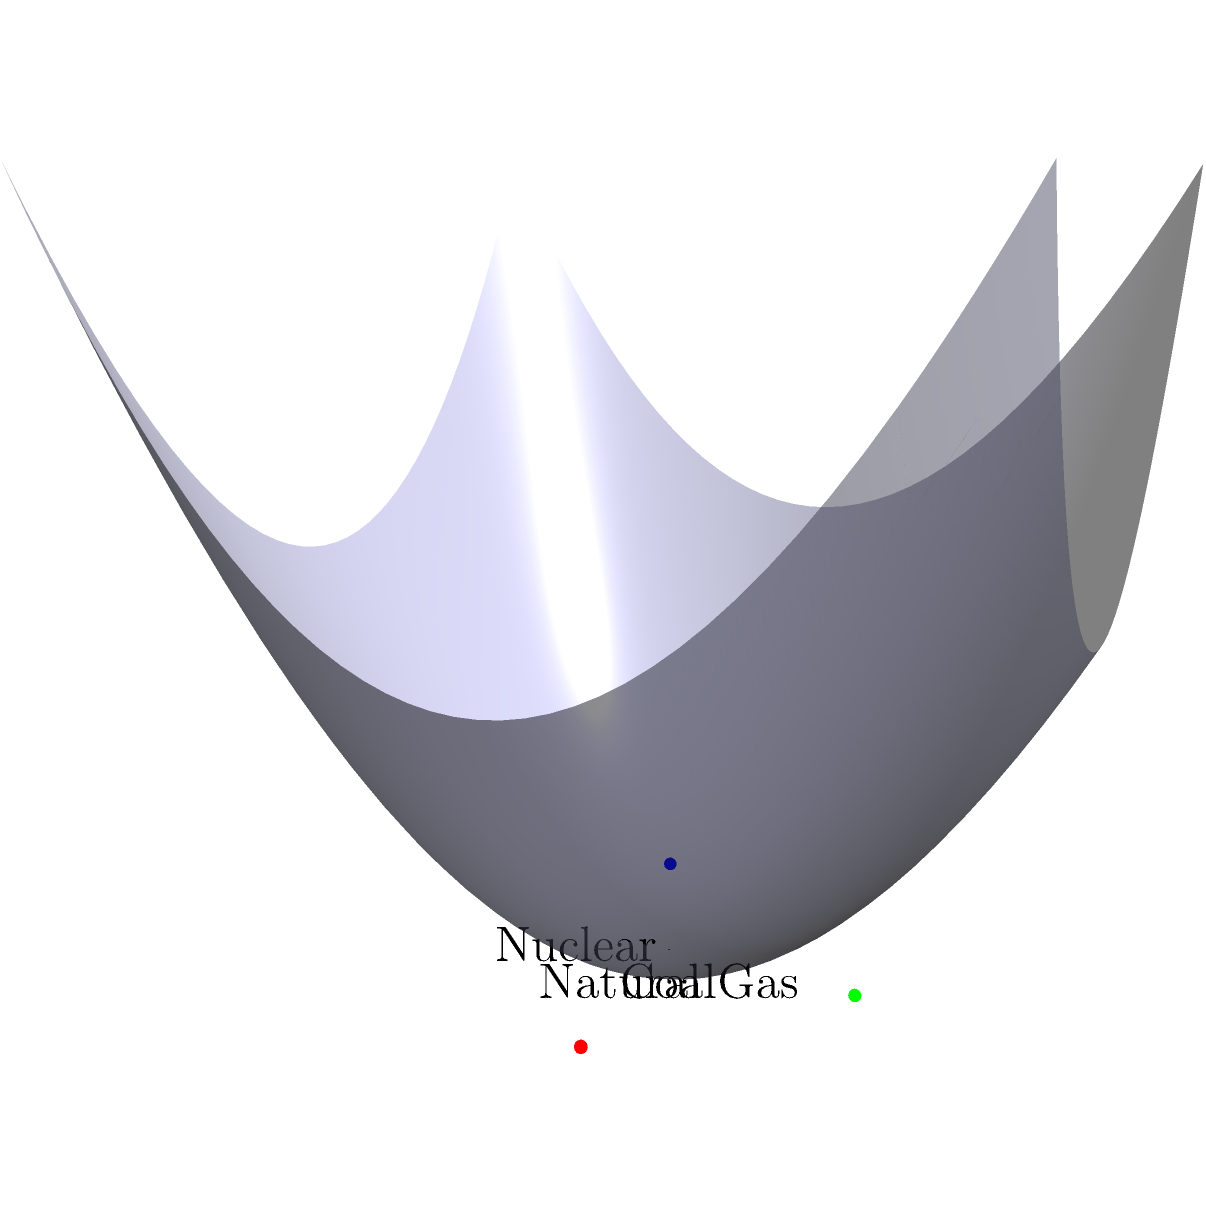In the 3D coordinate system shown, each axis represents the CO₂ emissions (in grams per kilowatt-hour) from different energy sources: Coal (x-axis), Natural Gas (y-axis), and Nuclear (z-axis). Given that Coal emits approximately 1000g CO₂/kWh, Natural Gas emits about 500g CO₂/kWh, and Nuclear emits roughly 12g CO₂/kWh, which energy source is represented by the blue dot in the diagram? To determine which energy source is represented by the blue dot, let's analyze the position of the dot in relation to each axis:

1. The blue dot is located at the point (0, 0, 1) in the 3D coordinate system.
2. This means it has no value on the x-axis (Coal) or y-axis (Natural Gas), but has a value of 1 on the z-axis (Nuclear).
3. The z-axis represents Nuclear energy, which has the lowest CO₂ emissions among the three sources at approximately 12g CO₂/kWh.
4. The position of the blue dot at (0, 0, 1) indicates that it represents the energy source with the lowest emissions, which aligns with Nuclear energy.
5. In contrast, the red dot at (1, 0, 0) likely represents Coal (highest emissions), and the green dot at (0, 1, 0) likely represents Natural Gas (medium emissions).

Therefore, based on the position of the blue dot and the given information about CO₂ emissions, the blue dot represents Nuclear energy.
Answer: Nuclear 